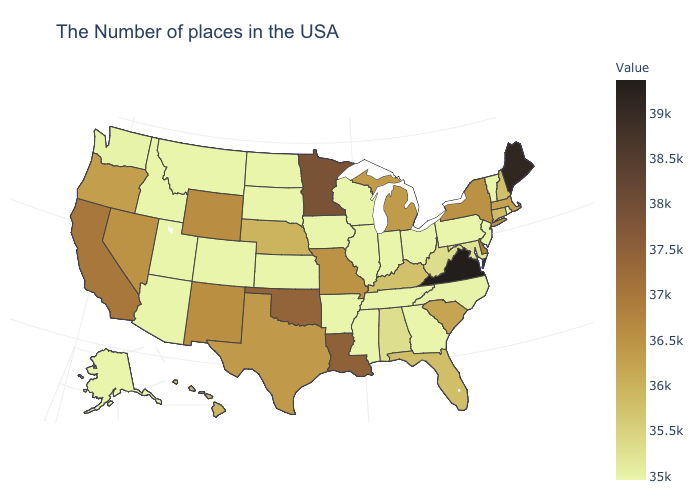Does Wisconsin have the highest value in the MidWest?
Concise answer only. No. Does Maine have the highest value in the Northeast?
Keep it brief. Yes. Which states have the lowest value in the MidWest?
Give a very brief answer. Ohio, Indiana, Wisconsin, Illinois, Iowa, Kansas, South Dakota, North Dakota. Which states hav the highest value in the West?
Write a very short answer. California. 